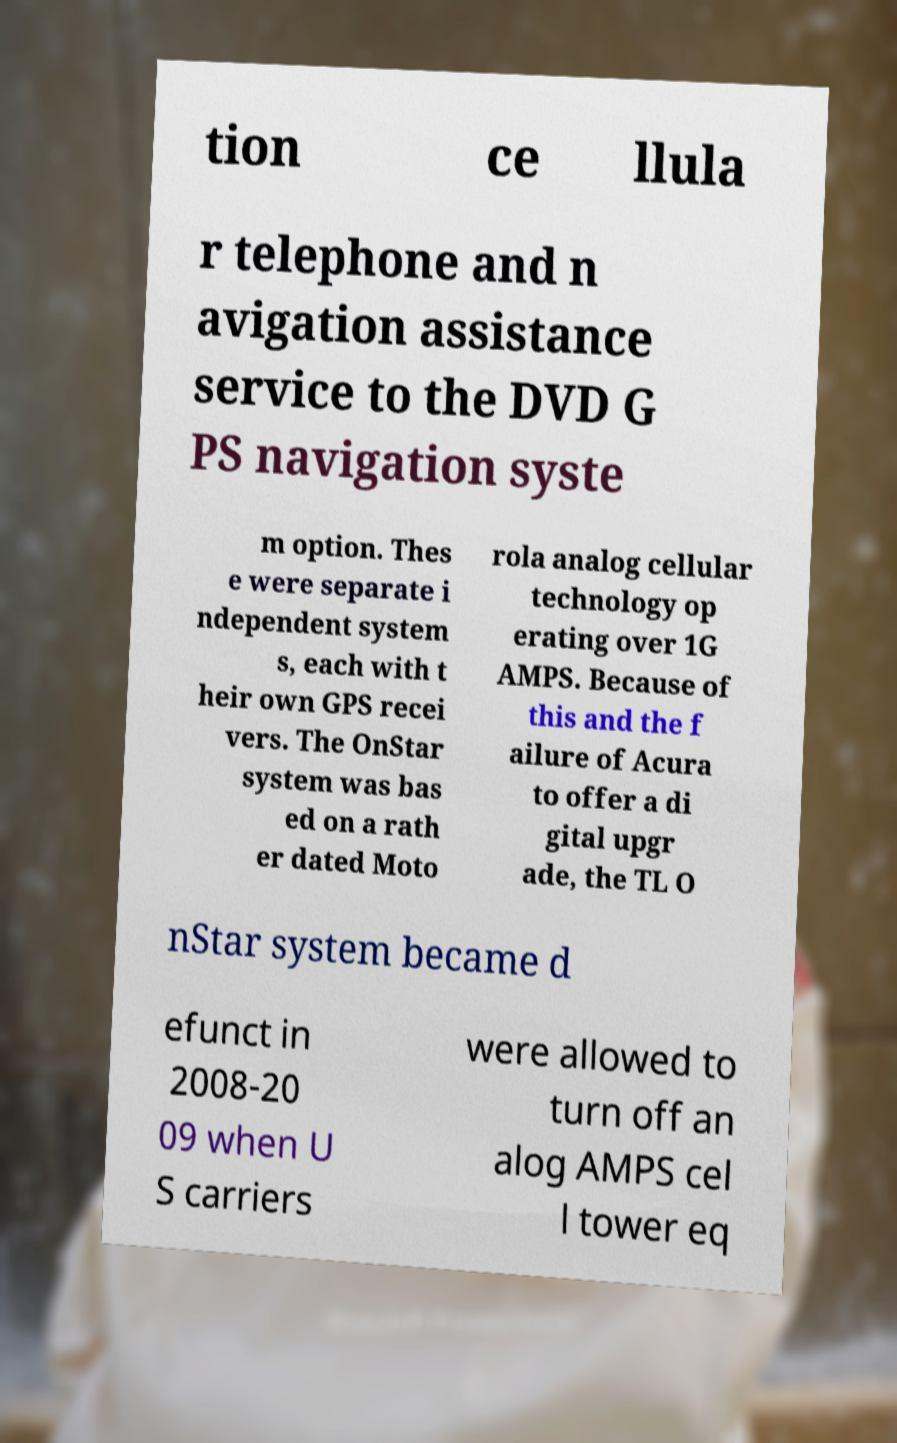Can you accurately transcribe the text from the provided image for me? tion ce llula r telephone and n avigation assistance service to the DVD G PS navigation syste m option. Thes e were separate i ndependent system s, each with t heir own GPS recei vers. The OnStar system was bas ed on a rath er dated Moto rola analog cellular technology op erating over 1G AMPS. Because of this and the f ailure of Acura to offer a di gital upgr ade, the TL O nStar system became d efunct in 2008-20 09 when U S carriers were allowed to turn off an alog AMPS cel l tower eq 